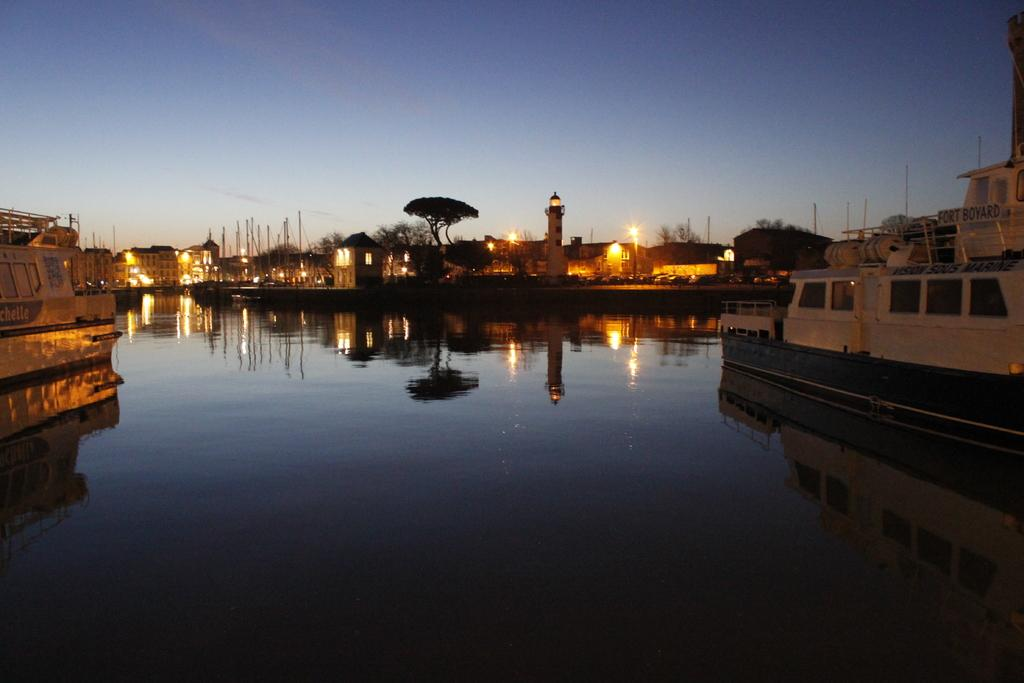What is happening on the water in the image? There are boats on water in the image. What type of vegetation can be seen in the image? There are trees in the image. What type of structures are visible in the image? There are buildings in the image. What can be seen illuminating the scene in the image? There are lights in the image. What objects are supporting the lights in the image? There are poles in the image. What is visible in the background of the image? The sky is visible in the background of the image. Where is the queen sitting on a swing in the image? There is no queen or swing present in the image. What type of twig is being used as a decoration in the image? There is no twig present in the image. 